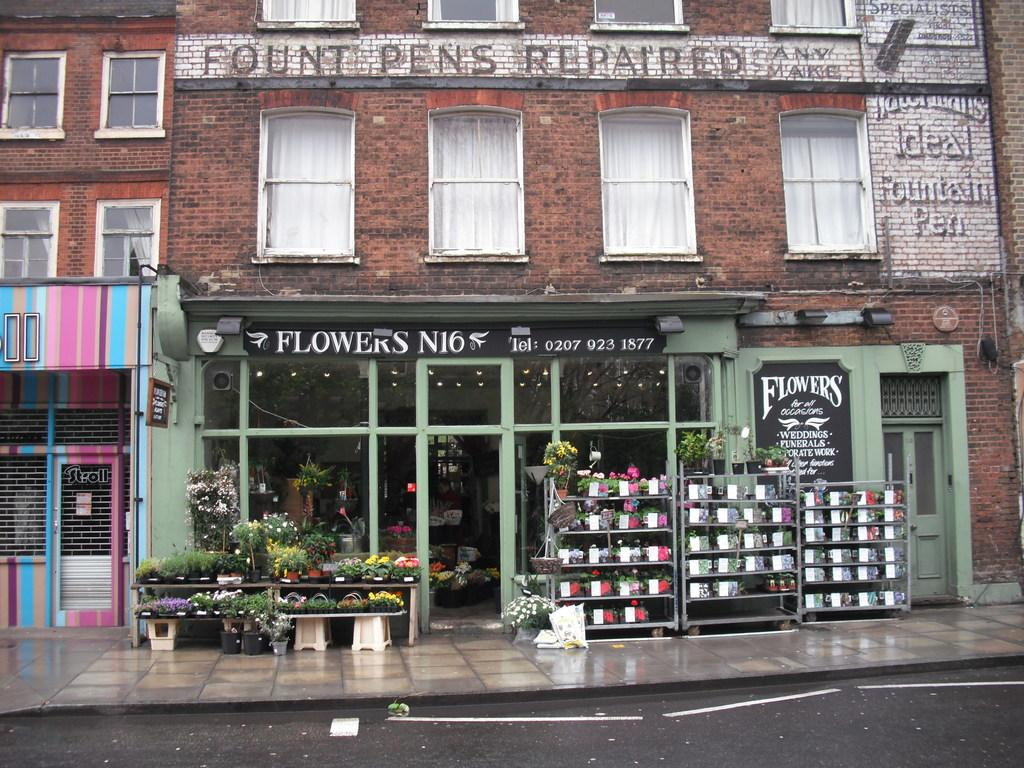<image>
Share a concise interpretation of the image provided. A store that says flowers on the front 